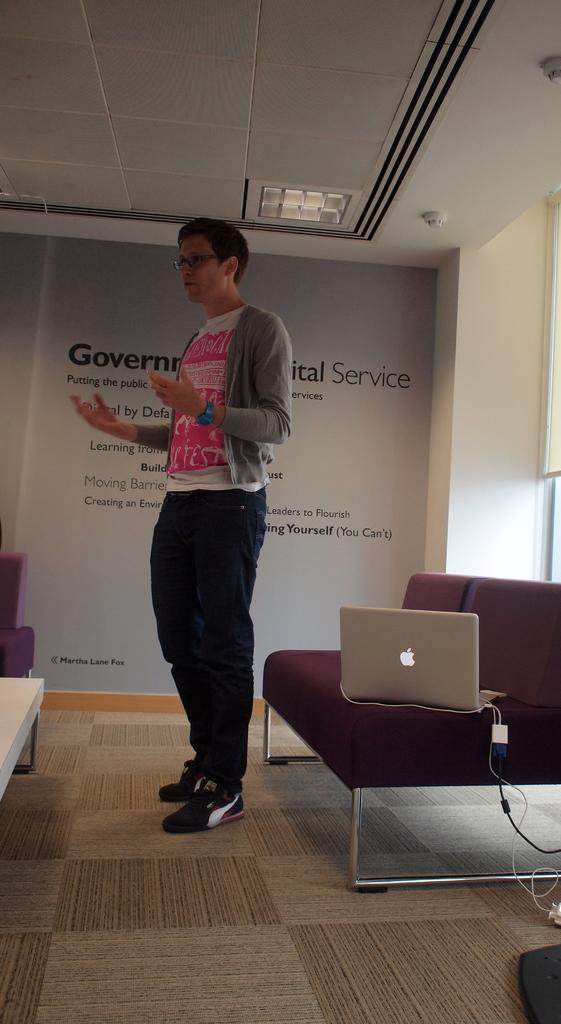Who is in the room? There is a man in the room. What piece of furniture is in the room? There is a sofa in the room. What is placed on the sofa? A laptop is present on the sofa. Are there any accessories related to the laptop? Yes, there are cables associated with the laptop. What can be seen on the wall behind the man? There is a banner on the wall behind the man. What is written on the banner? The banner has text on it. What type of tooth is visible on the banner? There is no tooth present on the banner; it has text on it. What is the man hoping for in the image? The image does not provide any information about the man's hopes or desires. 